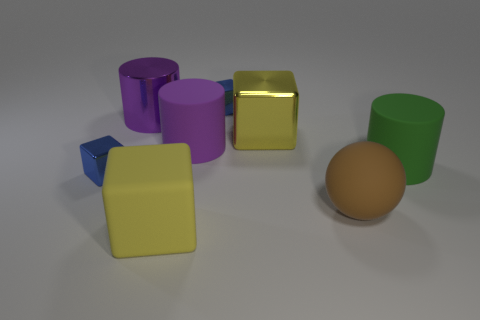Subtract all big rubber cylinders. How many cylinders are left? 1 Subtract all purple cubes. How many purple cylinders are left? 2 Add 2 blue cubes. How many objects exist? 10 Subtract all spheres. How many objects are left? 7 Subtract all blue cylinders. Subtract all purple balls. How many cylinders are left? 3 Subtract 0 cyan cylinders. How many objects are left? 8 Subtract all gray shiny objects. Subtract all large purple things. How many objects are left? 6 Add 3 small metallic things. How many small metallic things are left? 5 Add 6 tiny blue objects. How many tiny blue objects exist? 8 